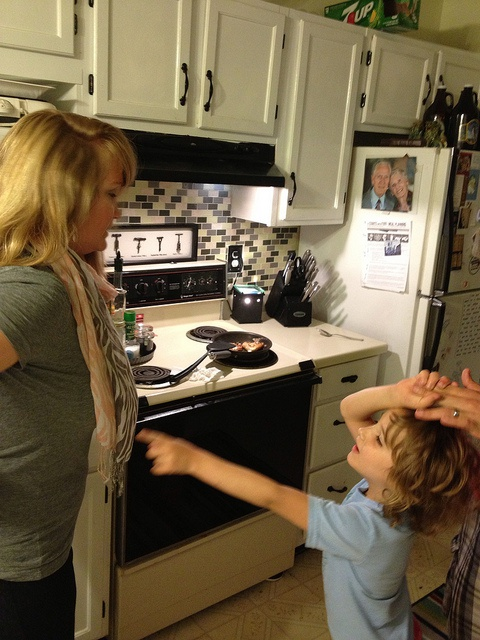Describe the objects in this image and their specific colors. I can see people in tan, black, olive, and maroon tones, oven in tan, black, olive, and maroon tones, refrigerator in tan, ivory, gray, and black tones, people in tan, darkgray, black, and gray tones, and people in tan, black, maroon, and brown tones in this image. 